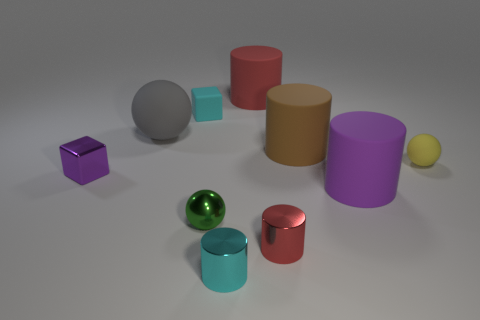Subtract all tiny metallic cylinders. How many cylinders are left? 3 Subtract all cyan cylinders. How many cylinders are left? 4 Subtract all purple cylinders. Subtract all purple balls. How many cylinders are left? 4 Subtract all spheres. How many objects are left? 7 Add 6 tiny yellow balls. How many tiny yellow balls are left? 7 Add 1 big red objects. How many big red objects exist? 2 Subtract 0 brown blocks. How many objects are left? 10 Subtract all big blue metal blocks. Subtract all large gray matte objects. How many objects are left? 9 